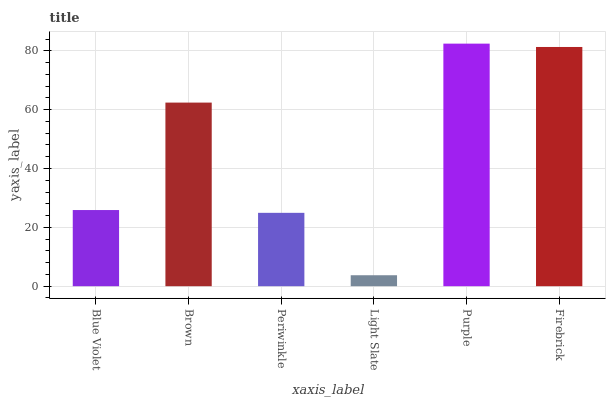Is Light Slate the minimum?
Answer yes or no. Yes. Is Purple the maximum?
Answer yes or no. Yes. Is Brown the minimum?
Answer yes or no. No. Is Brown the maximum?
Answer yes or no. No. Is Brown greater than Blue Violet?
Answer yes or no. Yes. Is Blue Violet less than Brown?
Answer yes or no. Yes. Is Blue Violet greater than Brown?
Answer yes or no. No. Is Brown less than Blue Violet?
Answer yes or no. No. Is Brown the high median?
Answer yes or no. Yes. Is Blue Violet the low median?
Answer yes or no. Yes. Is Purple the high median?
Answer yes or no. No. Is Light Slate the low median?
Answer yes or no. No. 